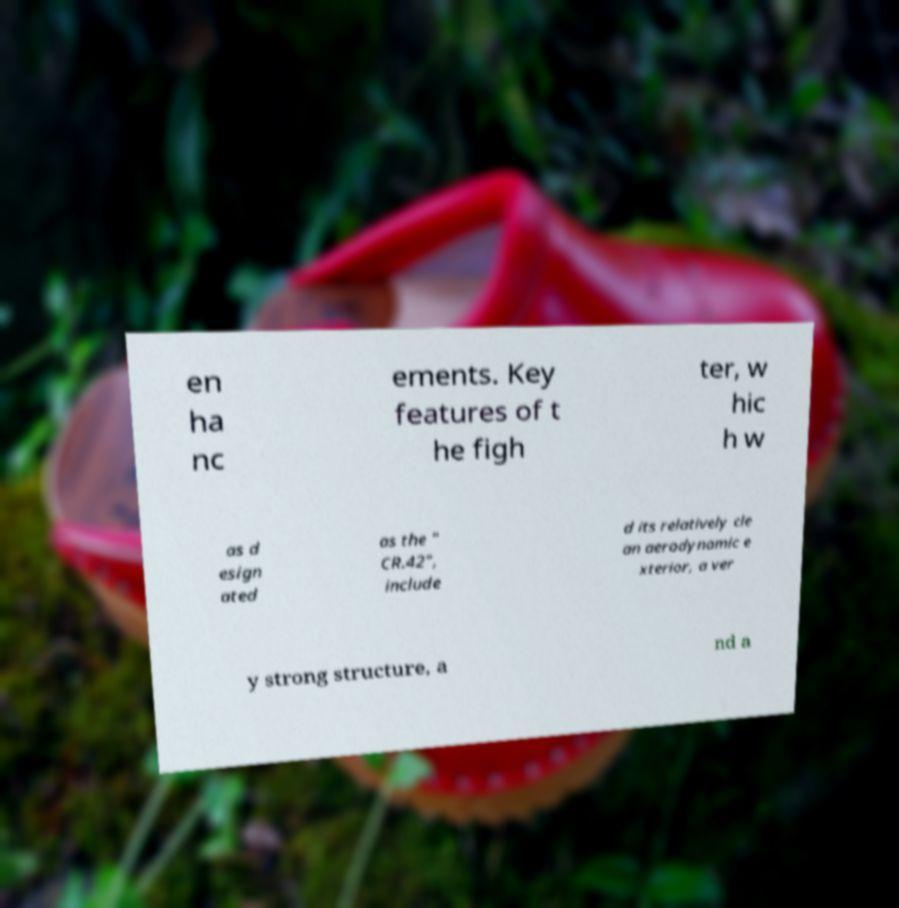What messages or text are displayed in this image? I need them in a readable, typed format. en ha nc ements. Key features of t he figh ter, w hic h w as d esign ated as the " CR.42", include d its relatively cle an aerodynamic e xterior, a ver y strong structure, a nd a 